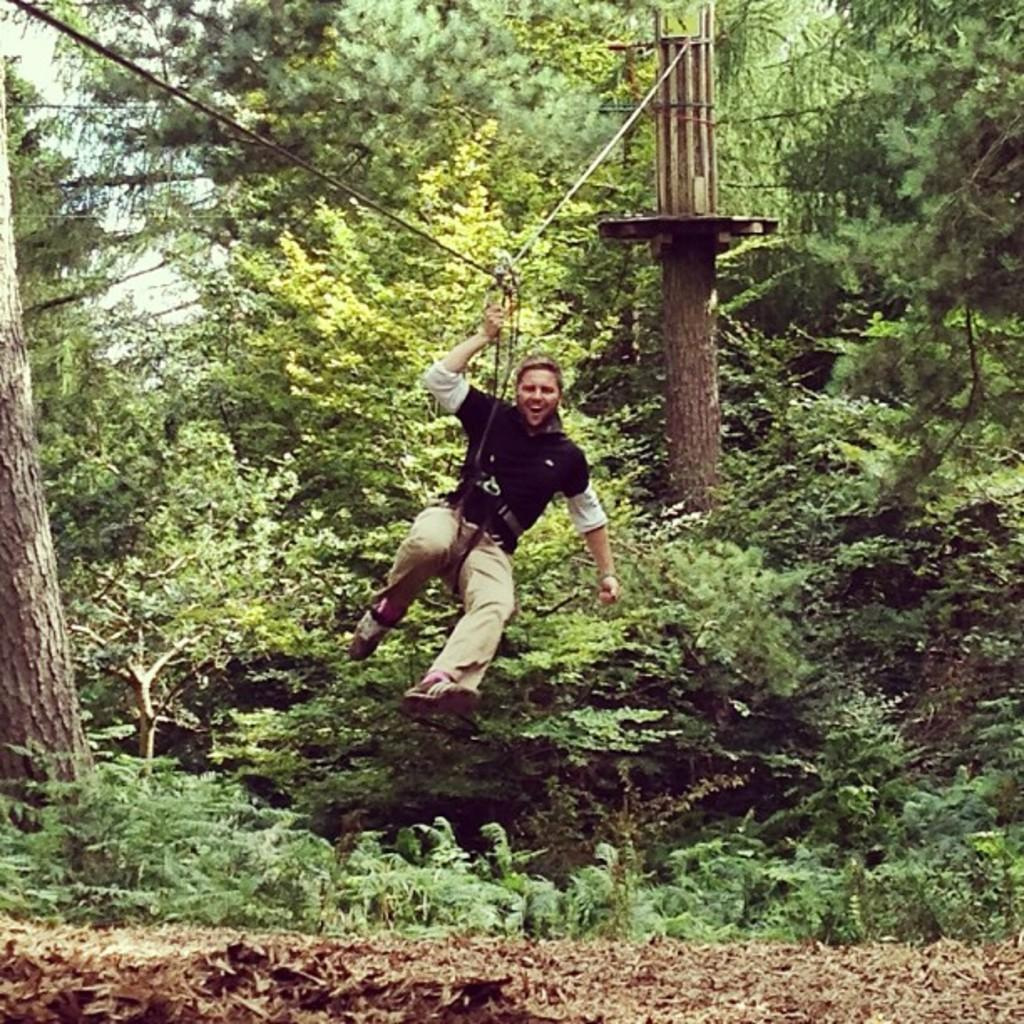What type of environment is shown in the image? The image depicts a forest area. What can be found in the forest area? There are trees and plants in the forest area. Are there any structures or objects in the image? Yes, there are two pillars with a wire in the image. What is happening to the person in the image? A person is tied to the wire. How many lizards are playing the guitar in the image? There are no lizards or guitars present in the image. Who is the owner of the forest in the image? The image does not provide information about the ownership of the forest. 